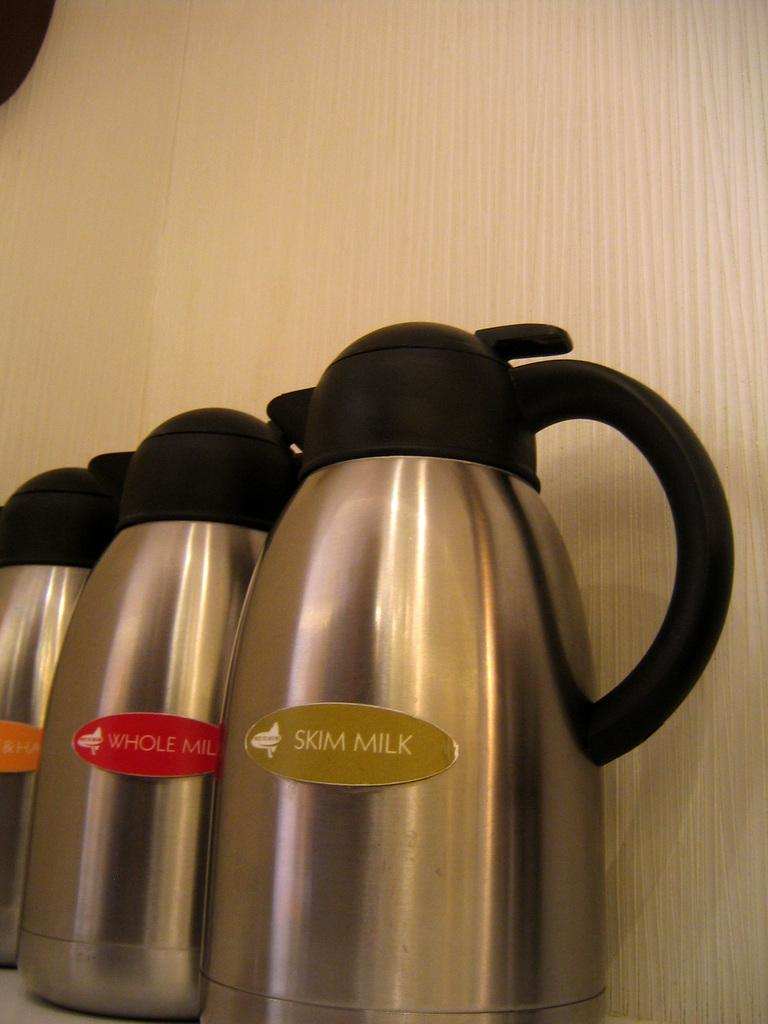What type of containers are present in the image? There are three steel flasks in the image. What distinguishes the flasks from one another? The flasks have stickers in orange, red, and green colors. What can be seen in the background of the image? There is a wall visible in the background of the image. How many seeds are visible on the orange sticker of the flask? There are no seeds present in the image; the flasks have stickers in orange, red, and green colors, but they do not depict seeds. 